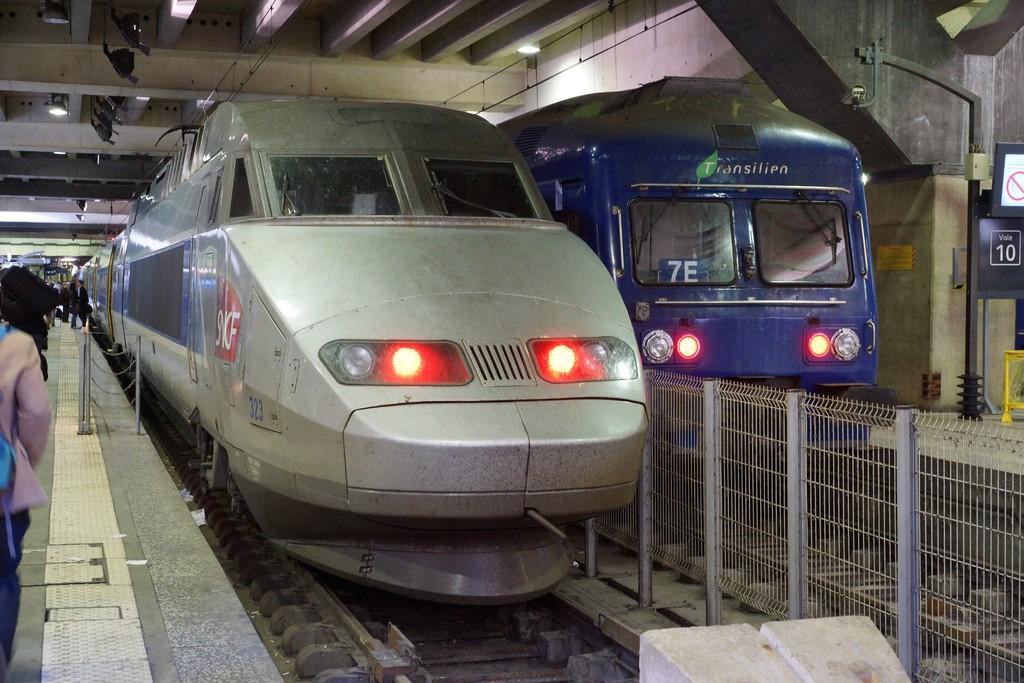What number is displayed in the window of the blue train?
Offer a very short reply. 7e. What does the blue subway have written on it?
Your response must be concise. Transilien. 